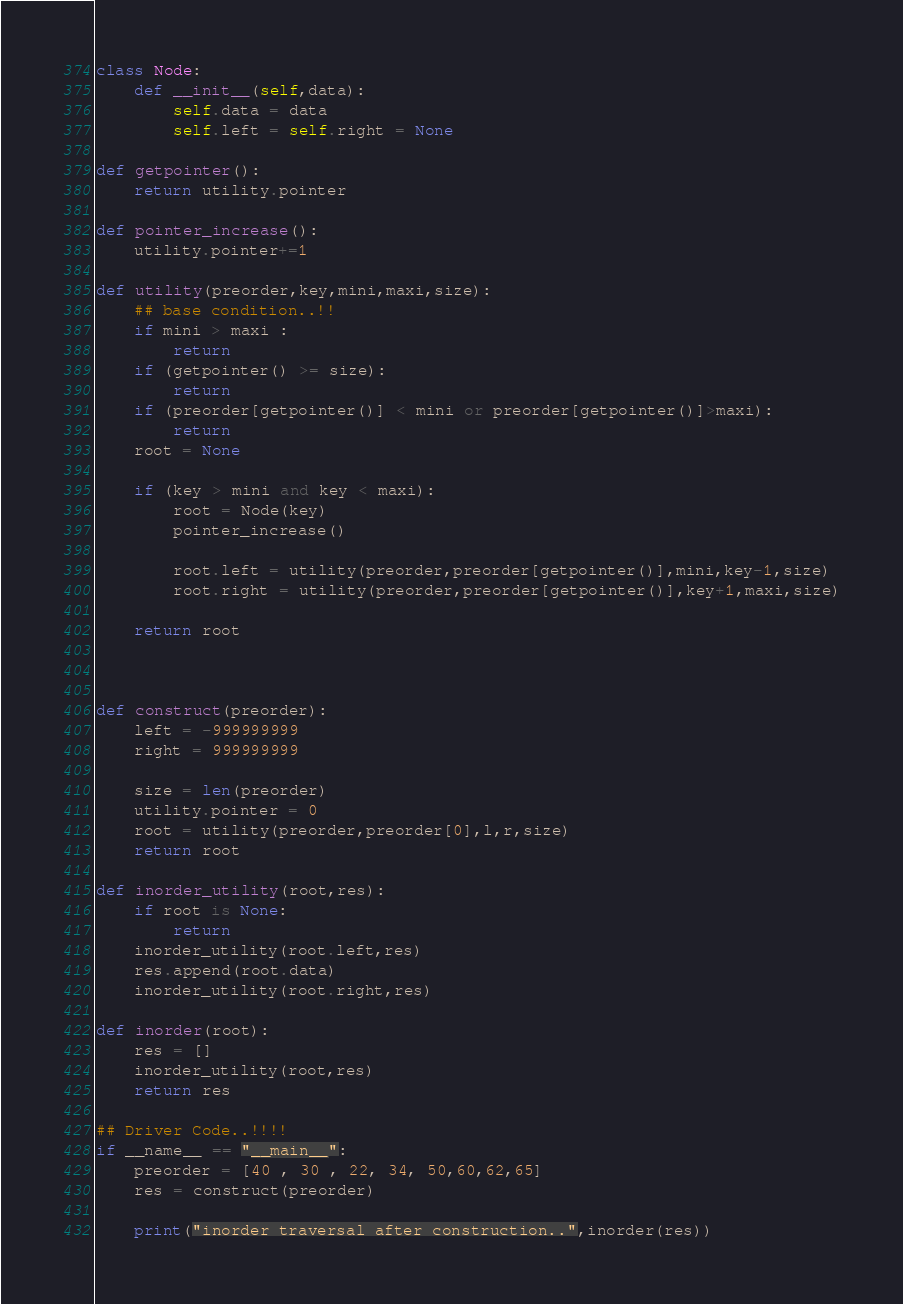Convert code to text. <code><loc_0><loc_0><loc_500><loc_500><_Python_>class Node:
    def __init__(self,data):
        self.data = data
        self.left = self.right = None
        
def getpointer():
    return utility.pointer

def pointer_increase():
    utility.pointer+=1
    
def utility(preorder,key,mini,maxi,size):
    ## base condition..!!
    if mini > maxi :
        return 
    if (getpointer() >= size):
        return 
    if (preorder[getpointer()] < mini or preorder[getpointer()]>maxi):
        return
    root = None
    
    if (key > mini and key < maxi):
        root = Node(key)
        pointer_increase()
        
        root.left = utility(preorder,preorder[getpointer()],mini,key-1,size)
        root.right = utility(preorder,preorder[getpointer()],key+1,maxi,size)
        
    return root
        
        
    
def construct(preorder):
    left = -999999999
    right = 999999999
    
    size = len(preorder)
    utility.pointer = 0
    root = utility(preorder,preorder[0],l,r,size)
    return root
    
def inorder_utility(root,res):
    if root is None:
        return 
    inorder_utility(root.left,res)
    res.append(root.data)
    inorder_utility(root.right,res)

def inorder(root):
    res = []
    inorder_utility(root,res)
    return res
    
## Driver Code..!!!!
if __name__ == "__main__":
    preorder = [40 , 30 , 22, 34, 50,60,62,65]
    res = construct(preorder)
    
    print("inorder traversal after construction..",inorder(res))</code> 